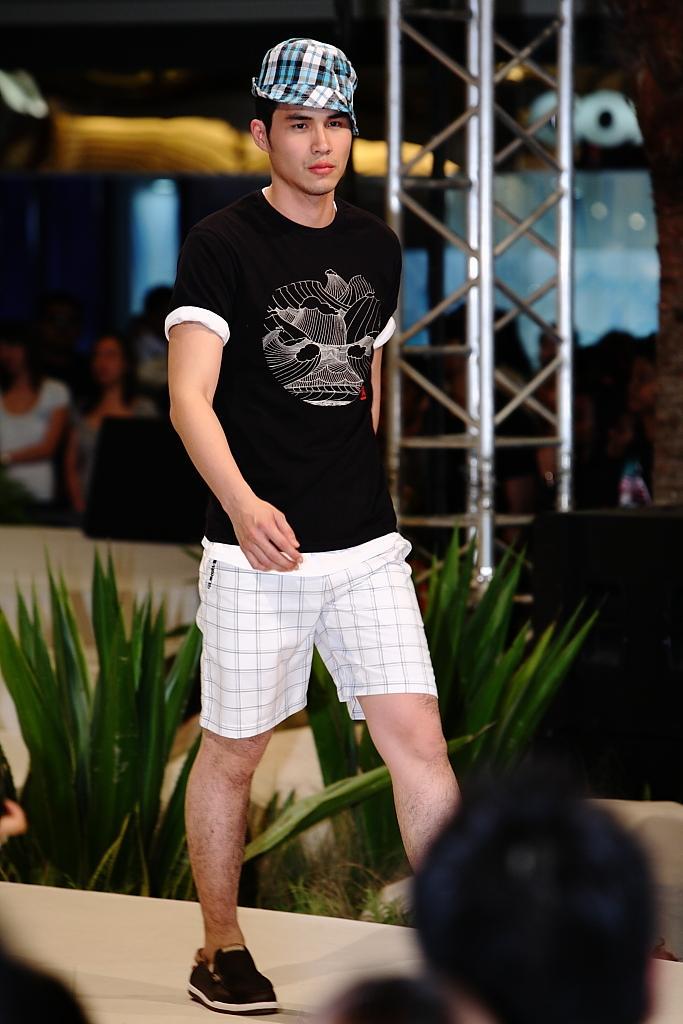Can you describe this image briefly? In this image I can see a person standing and the person is wearing black shirt, white short, background I can see few leaves in green color, a pole, few persons and few windows. 